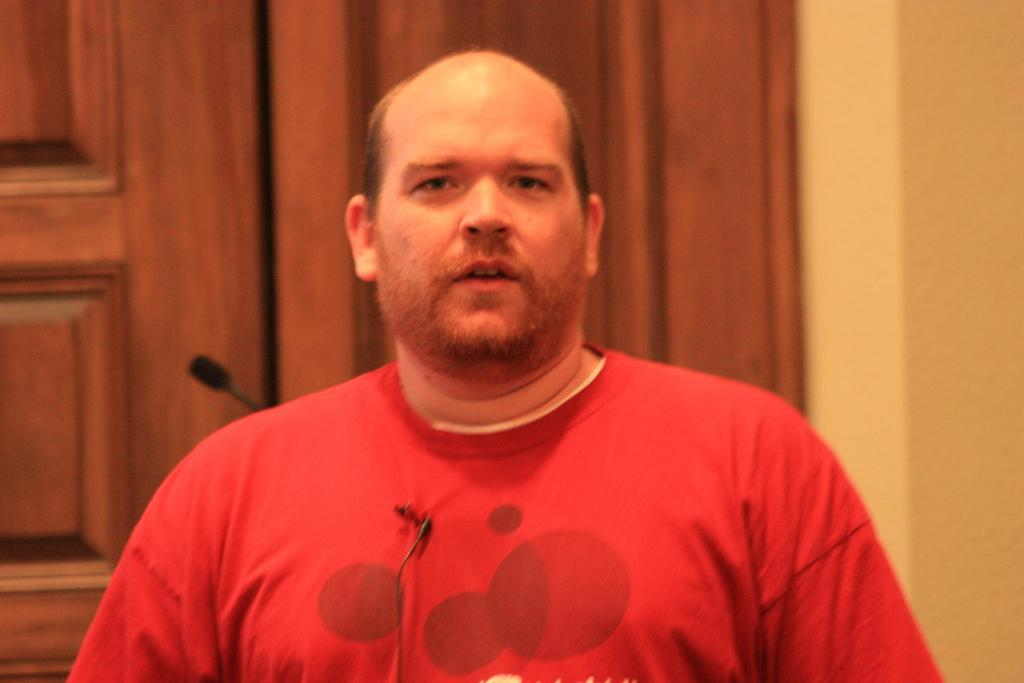Who is the main subject in the image? There is a man in the center of the image. What is the man wearing? The man is wearing a red shirt. What can be seen in the background of the image? There is a mic, a door, and a wall in the background of the image. What type of car is the man trying to attract the attention of in the image? There is no car present in the image, and the man is not trying to attract anyone's attention. 